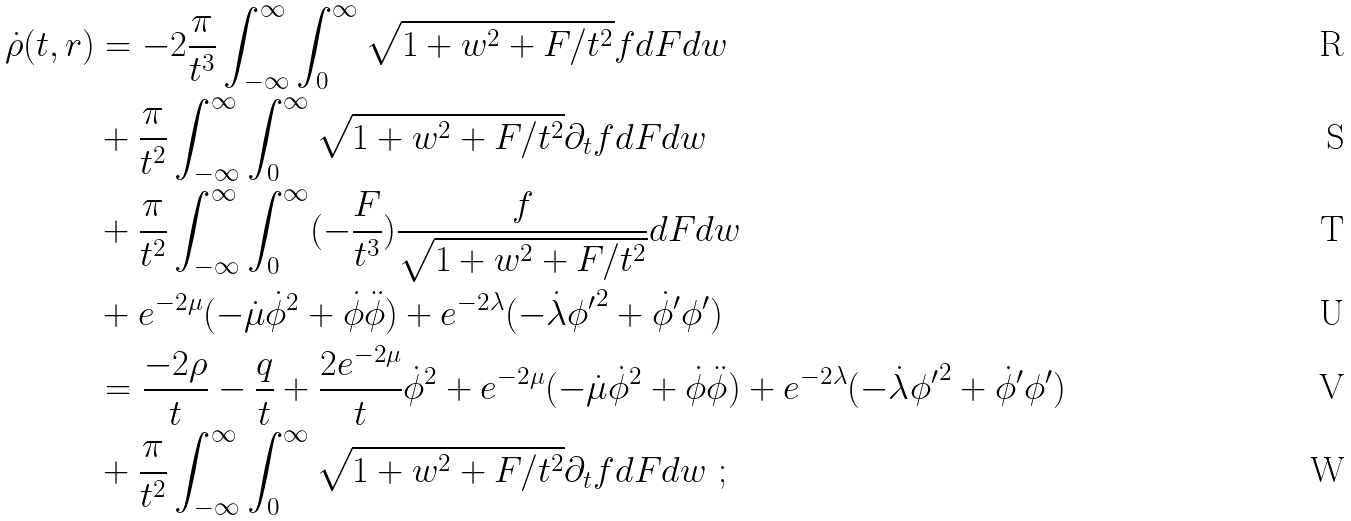<formula> <loc_0><loc_0><loc_500><loc_500>\dot { \rho } ( t , r ) & = - 2 \frac { \pi } { t ^ { 3 } } \int _ { - \infty } ^ { \infty } \int _ { 0 } ^ { \infty } \sqrt { 1 + w ^ { 2 } + F / { t ^ { 2 } } } f d F d w \\ & + \frac { \pi } { t ^ { 2 } } \int _ { - \infty } ^ { \infty } \int _ { 0 } ^ { \infty } \sqrt { 1 + w ^ { 2 } + F / { t ^ { 2 } } } \partial _ { t } f d F d w \\ & + \frac { \pi } { t ^ { 2 } } \int _ { - \infty } ^ { \infty } \int _ { 0 } ^ { \infty } ( - \frac { F } { t ^ { 3 } } ) \frac { f } { \sqrt { 1 + w ^ { 2 } + F / { t ^ { 2 } } } } d F d w \\ & + e ^ { - 2 \mu } ( - \dot { \mu } \dot { \phi } ^ { 2 } + \dot { \phi } \ddot { \phi } ) + e ^ { - 2 \lambda } ( - \dot { \lambda } { \phi ^ { \prime } } ^ { 2 } + \dot { \phi } ^ { \prime } \phi ^ { \prime } ) \\ & = \frac { - 2 \rho } { t } - \frac { q } { t } + \frac { 2 e ^ { - 2 \mu } } { t } \dot { \phi } ^ { 2 } + e ^ { - 2 \mu } ( - \dot { \mu } \dot { \phi } ^ { 2 } + \dot { \phi } \ddot { \phi } ) + e ^ { - 2 \lambda } ( - \dot { \lambda } { \phi ^ { \prime } } ^ { 2 } + \dot { \phi } ^ { \prime } \phi ^ { \prime } ) \\ & + \frac { \pi } { t ^ { 2 } } \int _ { - \infty } ^ { \infty } \int _ { 0 } ^ { \infty } \sqrt { 1 + w ^ { 2 } + F / { t ^ { 2 } } } \partial _ { t } f d F d w \ ;</formula> 